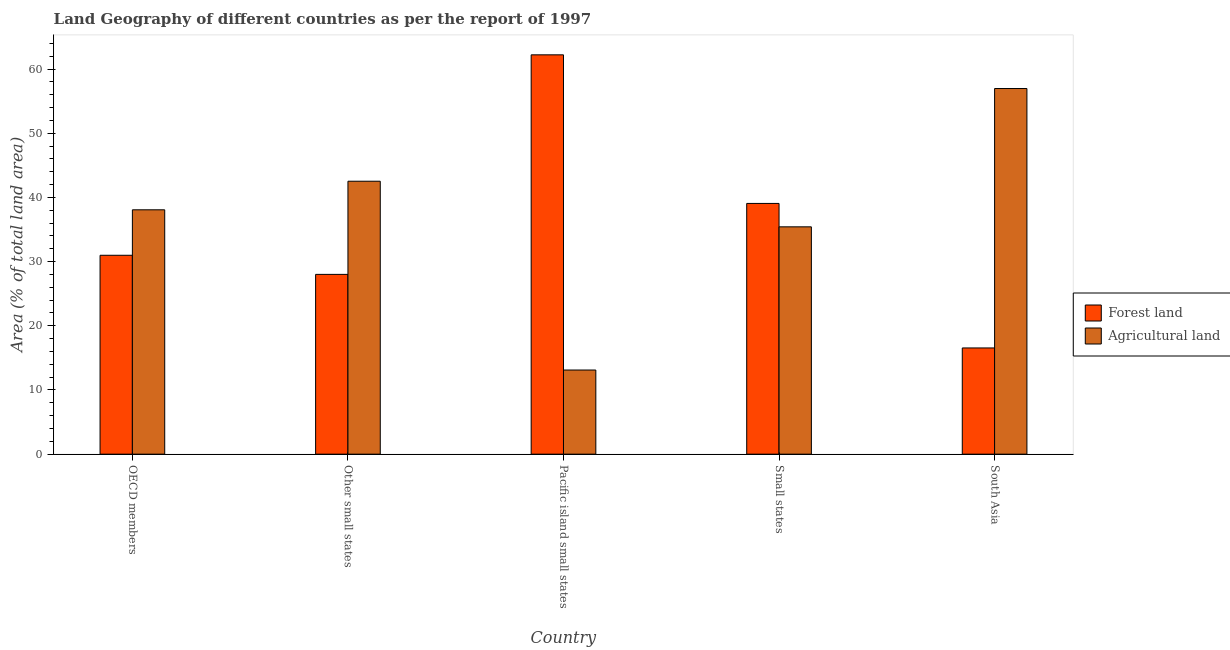How many groups of bars are there?
Provide a succinct answer. 5. Are the number of bars per tick equal to the number of legend labels?
Your response must be concise. Yes. Are the number of bars on each tick of the X-axis equal?
Your response must be concise. Yes. How many bars are there on the 5th tick from the left?
Keep it short and to the point. 2. What is the label of the 3rd group of bars from the left?
Your answer should be very brief. Pacific island small states. In how many cases, is the number of bars for a given country not equal to the number of legend labels?
Offer a terse response. 0. What is the percentage of land area under forests in South Asia?
Offer a terse response. 16.55. Across all countries, what is the maximum percentage of land area under agriculture?
Give a very brief answer. 56.97. Across all countries, what is the minimum percentage of land area under agriculture?
Give a very brief answer. 13.11. In which country was the percentage of land area under agriculture maximum?
Offer a terse response. South Asia. In which country was the percentage of land area under agriculture minimum?
Offer a very short reply. Pacific island small states. What is the total percentage of land area under forests in the graph?
Provide a short and direct response. 176.85. What is the difference between the percentage of land area under forests in Small states and that in South Asia?
Your response must be concise. 22.52. What is the difference between the percentage of land area under agriculture in South Asia and the percentage of land area under forests in Other small states?
Provide a succinct answer. 28.96. What is the average percentage of land area under agriculture per country?
Keep it short and to the point. 37.22. What is the difference between the percentage of land area under agriculture and percentage of land area under forests in OECD members?
Ensure brevity in your answer.  7.09. What is the ratio of the percentage of land area under agriculture in Small states to that in South Asia?
Keep it short and to the point. 0.62. Is the difference between the percentage of land area under agriculture in Other small states and South Asia greater than the difference between the percentage of land area under forests in Other small states and South Asia?
Keep it short and to the point. No. What is the difference between the highest and the second highest percentage of land area under agriculture?
Your response must be concise. 14.45. What is the difference between the highest and the lowest percentage of land area under agriculture?
Keep it short and to the point. 43.86. In how many countries, is the percentage of land area under forests greater than the average percentage of land area under forests taken over all countries?
Your answer should be compact. 2. Is the sum of the percentage of land area under forests in Other small states and South Asia greater than the maximum percentage of land area under agriculture across all countries?
Make the answer very short. No. What does the 2nd bar from the left in Small states represents?
Make the answer very short. Agricultural land. What does the 2nd bar from the right in OECD members represents?
Your response must be concise. Forest land. Are all the bars in the graph horizontal?
Offer a terse response. No. How many countries are there in the graph?
Provide a succinct answer. 5. Are the values on the major ticks of Y-axis written in scientific E-notation?
Provide a succinct answer. No. Does the graph contain any zero values?
Offer a terse response. No. Does the graph contain grids?
Your response must be concise. No. Where does the legend appear in the graph?
Offer a very short reply. Center right. How are the legend labels stacked?
Keep it short and to the point. Vertical. What is the title of the graph?
Offer a terse response. Land Geography of different countries as per the report of 1997. Does "Current education expenditure" appear as one of the legend labels in the graph?
Offer a terse response. No. What is the label or title of the Y-axis?
Your answer should be very brief. Area (% of total land area). What is the Area (% of total land area) in Forest land in OECD members?
Make the answer very short. 30.99. What is the Area (% of total land area) in Agricultural land in OECD members?
Make the answer very short. 38.08. What is the Area (% of total land area) in Forest land in Other small states?
Offer a very short reply. 28.01. What is the Area (% of total land area) of Agricultural land in Other small states?
Provide a succinct answer. 42.53. What is the Area (% of total land area) in Forest land in Pacific island small states?
Your answer should be very brief. 62.22. What is the Area (% of total land area) of Agricultural land in Pacific island small states?
Your response must be concise. 13.11. What is the Area (% of total land area) of Forest land in Small states?
Give a very brief answer. 39.07. What is the Area (% of total land area) of Agricultural land in Small states?
Your answer should be compact. 35.42. What is the Area (% of total land area) in Forest land in South Asia?
Your response must be concise. 16.55. What is the Area (% of total land area) of Agricultural land in South Asia?
Ensure brevity in your answer.  56.97. Across all countries, what is the maximum Area (% of total land area) in Forest land?
Provide a succinct answer. 62.22. Across all countries, what is the maximum Area (% of total land area) of Agricultural land?
Give a very brief answer. 56.97. Across all countries, what is the minimum Area (% of total land area) in Forest land?
Ensure brevity in your answer.  16.55. Across all countries, what is the minimum Area (% of total land area) of Agricultural land?
Your response must be concise. 13.11. What is the total Area (% of total land area) of Forest land in the graph?
Provide a succinct answer. 176.85. What is the total Area (% of total land area) in Agricultural land in the graph?
Make the answer very short. 186.11. What is the difference between the Area (% of total land area) in Forest land in OECD members and that in Other small states?
Provide a short and direct response. 2.98. What is the difference between the Area (% of total land area) of Agricultural land in OECD members and that in Other small states?
Provide a short and direct response. -4.45. What is the difference between the Area (% of total land area) of Forest land in OECD members and that in Pacific island small states?
Keep it short and to the point. -31.23. What is the difference between the Area (% of total land area) in Agricultural land in OECD members and that in Pacific island small states?
Your response must be concise. 24.96. What is the difference between the Area (% of total land area) of Forest land in OECD members and that in Small states?
Ensure brevity in your answer.  -8.08. What is the difference between the Area (% of total land area) of Agricultural land in OECD members and that in Small states?
Offer a very short reply. 2.65. What is the difference between the Area (% of total land area) in Forest land in OECD members and that in South Asia?
Provide a succinct answer. 14.44. What is the difference between the Area (% of total land area) of Agricultural land in OECD members and that in South Asia?
Keep it short and to the point. -18.9. What is the difference between the Area (% of total land area) of Forest land in Other small states and that in Pacific island small states?
Your answer should be very brief. -34.21. What is the difference between the Area (% of total land area) in Agricultural land in Other small states and that in Pacific island small states?
Offer a very short reply. 29.42. What is the difference between the Area (% of total land area) in Forest land in Other small states and that in Small states?
Your answer should be compact. -11.06. What is the difference between the Area (% of total land area) in Agricultural land in Other small states and that in Small states?
Give a very brief answer. 7.1. What is the difference between the Area (% of total land area) in Forest land in Other small states and that in South Asia?
Your response must be concise. 11.46. What is the difference between the Area (% of total land area) in Agricultural land in Other small states and that in South Asia?
Offer a terse response. -14.45. What is the difference between the Area (% of total land area) in Forest land in Pacific island small states and that in Small states?
Your answer should be very brief. 23.15. What is the difference between the Area (% of total land area) of Agricultural land in Pacific island small states and that in Small states?
Provide a succinct answer. -22.31. What is the difference between the Area (% of total land area) in Forest land in Pacific island small states and that in South Asia?
Your response must be concise. 45.67. What is the difference between the Area (% of total land area) of Agricultural land in Pacific island small states and that in South Asia?
Provide a succinct answer. -43.86. What is the difference between the Area (% of total land area) of Forest land in Small states and that in South Asia?
Keep it short and to the point. 22.52. What is the difference between the Area (% of total land area) of Agricultural land in Small states and that in South Asia?
Your answer should be compact. -21.55. What is the difference between the Area (% of total land area) in Forest land in OECD members and the Area (% of total land area) in Agricultural land in Other small states?
Provide a short and direct response. -11.54. What is the difference between the Area (% of total land area) of Forest land in OECD members and the Area (% of total land area) of Agricultural land in Pacific island small states?
Offer a very short reply. 17.88. What is the difference between the Area (% of total land area) in Forest land in OECD members and the Area (% of total land area) in Agricultural land in Small states?
Offer a terse response. -4.43. What is the difference between the Area (% of total land area) in Forest land in OECD members and the Area (% of total land area) in Agricultural land in South Asia?
Offer a very short reply. -25.98. What is the difference between the Area (% of total land area) of Forest land in Other small states and the Area (% of total land area) of Agricultural land in Pacific island small states?
Provide a short and direct response. 14.9. What is the difference between the Area (% of total land area) in Forest land in Other small states and the Area (% of total land area) in Agricultural land in Small states?
Your answer should be very brief. -7.41. What is the difference between the Area (% of total land area) of Forest land in Other small states and the Area (% of total land area) of Agricultural land in South Asia?
Keep it short and to the point. -28.96. What is the difference between the Area (% of total land area) in Forest land in Pacific island small states and the Area (% of total land area) in Agricultural land in Small states?
Your answer should be very brief. 26.8. What is the difference between the Area (% of total land area) in Forest land in Pacific island small states and the Area (% of total land area) in Agricultural land in South Asia?
Offer a terse response. 5.25. What is the difference between the Area (% of total land area) in Forest land in Small states and the Area (% of total land area) in Agricultural land in South Asia?
Provide a short and direct response. -17.9. What is the average Area (% of total land area) of Forest land per country?
Offer a terse response. 35.37. What is the average Area (% of total land area) in Agricultural land per country?
Your response must be concise. 37.22. What is the difference between the Area (% of total land area) in Forest land and Area (% of total land area) in Agricultural land in OECD members?
Your response must be concise. -7.09. What is the difference between the Area (% of total land area) of Forest land and Area (% of total land area) of Agricultural land in Other small states?
Offer a terse response. -14.51. What is the difference between the Area (% of total land area) in Forest land and Area (% of total land area) in Agricultural land in Pacific island small states?
Keep it short and to the point. 49.11. What is the difference between the Area (% of total land area) of Forest land and Area (% of total land area) of Agricultural land in Small states?
Your answer should be compact. 3.65. What is the difference between the Area (% of total land area) of Forest land and Area (% of total land area) of Agricultural land in South Asia?
Provide a short and direct response. -40.42. What is the ratio of the Area (% of total land area) of Forest land in OECD members to that in Other small states?
Keep it short and to the point. 1.11. What is the ratio of the Area (% of total land area) of Agricultural land in OECD members to that in Other small states?
Make the answer very short. 0.9. What is the ratio of the Area (% of total land area) of Forest land in OECD members to that in Pacific island small states?
Give a very brief answer. 0.5. What is the ratio of the Area (% of total land area) in Agricultural land in OECD members to that in Pacific island small states?
Keep it short and to the point. 2.9. What is the ratio of the Area (% of total land area) in Forest land in OECD members to that in Small states?
Offer a terse response. 0.79. What is the ratio of the Area (% of total land area) in Agricultural land in OECD members to that in Small states?
Offer a very short reply. 1.07. What is the ratio of the Area (% of total land area) in Forest land in OECD members to that in South Asia?
Your answer should be compact. 1.87. What is the ratio of the Area (% of total land area) in Agricultural land in OECD members to that in South Asia?
Keep it short and to the point. 0.67. What is the ratio of the Area (% of total land area) in Forest land in Other small states to that in Pacific island small states?
Ensure brevity in your answer.  0.45. What is the ratio of the Area (% of total land area) in Agricultural land in Other small states to that in Pacific island small states?
Your response must be concise. 3.24. What is the ratio of the Area (% of total land area) of Forest land in Other small states to that in Small states?
Your response must be concise. 0.72. What is the ratio of the Area (% of total land area) of Agricultural land in Other small states to that in Small states?
Offer a terse response. 1.2. What is the ratio of the Area (% of total land area) of Forest land in Other small states to that in South Asia?
Keep it short and to the point. 1.69. What is the ratio of the Area (% of total land area) in Agricultural land in Other small states to that in South Asia?
Offer a terse response. 0.75. What is the ratio of the Area (% of total land area) of Forest land in Pacific island small states to that in Small states?
Provide a short and direct response. 1.59. What is the ratio of the Area (% of total land area) in Agricultural land in Pacific island small states to that in Small states?
Offer a very short reply. 0.37. What is the ratio of the Area (% of total land area) of Forest land in Pacific island small states to that in South Asia?
Your answer should be compact. 3.76. What is the ratio of the Area (% of total land area) of Agricultural land in Pacific island small states to that in South Asia?
Provide a succinct answer. 0.23. What is the ratio of the Area (% of total land area) in Forest land in Small states to that in South Asia?
Provide a short and direct response. 2.36. What is the ratio of the Area (% of total land area) of Agricultural land in Small states to that in South Asia?
Keep it short and to the point. 0.62. What is the difference between the highest and the second highest Area (% of total land area) in Forest land?
Offer a terse response. 23.15. What is the difference between the highest and the second highest Area (% of total land area) in Agricultural land?
Keep it short and to the point. 14.45. What is the difference between the highest and the lowest Area (% of total land area) of Forest land?
Your answer should be compact. 45.67. What is the difference between the highest and the lowest Area (% of total land area) of Agricultural land?
Keep it short and to the point. 43.86. 